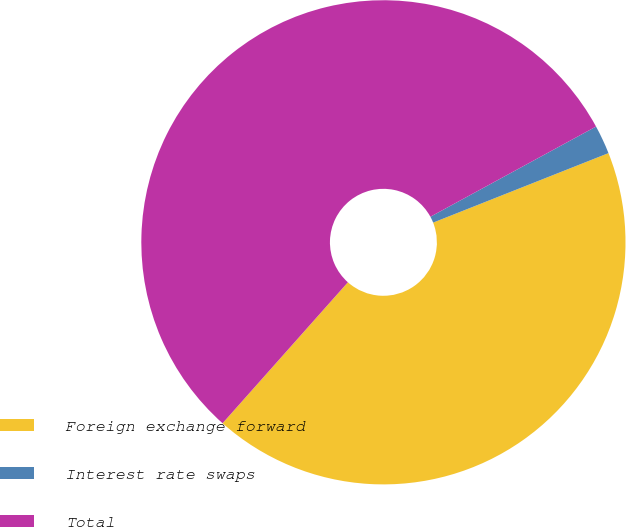Convert chart. <chart><loc_0><loc_0><loc_500><loc_500><pie_chart><fcel>Foreign exchange forward<fcel>Interest rate swaps<fcel>Total<nl><fcel>42.57%<fcel>1.93%<fcel>55.5%<nl></chart> 